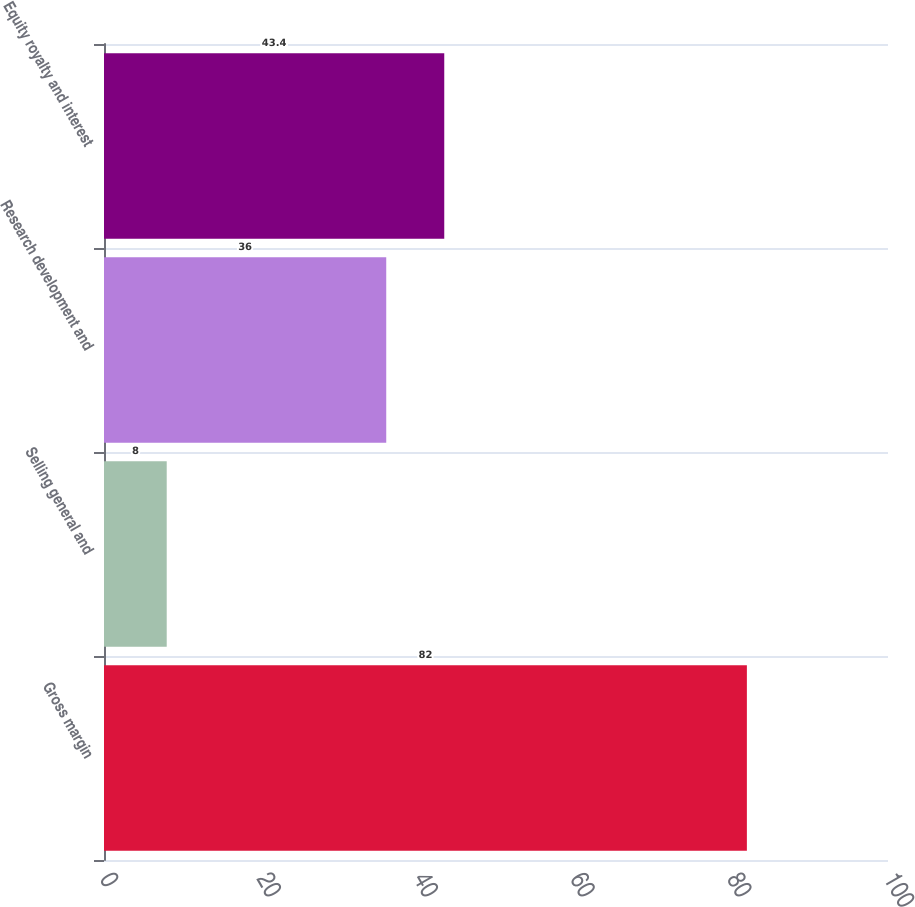Convert chart. <chart><loc_0><loc_0><loc_500><loc_500><bar_chart><fcel>Gross margin<fcel>Selling general and<fcel>Research development and<fcel>Equity royalty and interest<nl><fcel>82<fcel>8<fcel>36<fcel>43.4<nl></chart> 